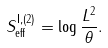Convert formula to latex. <formula><loc_0><loc_0><loc_500><loc_500>S ^ { \text {I} , ( 2 ) } _ { \text {eff} } = \log \frac { L ^ { 2 } } { \theta } .</formula> 